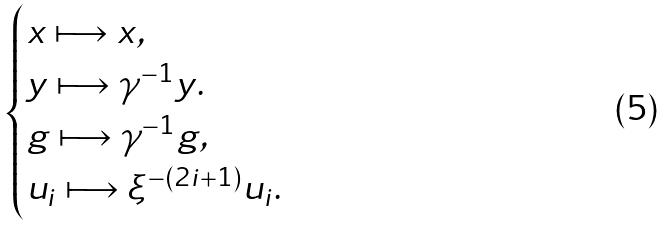<formula> <loc_0><loc_0><loc_500><loc_500>\begin{cases} x \longmapsto x , & \\ y \longmapsto \gamma ^ { - 1 } y . & \\ g \longmapsto \gamma ^ { - 1 } g , & \\ u _ { i } \longmapsto \xi ^ { - ( 2 i + 1 ) } u _ { i } . & \end{cases}</formula> 